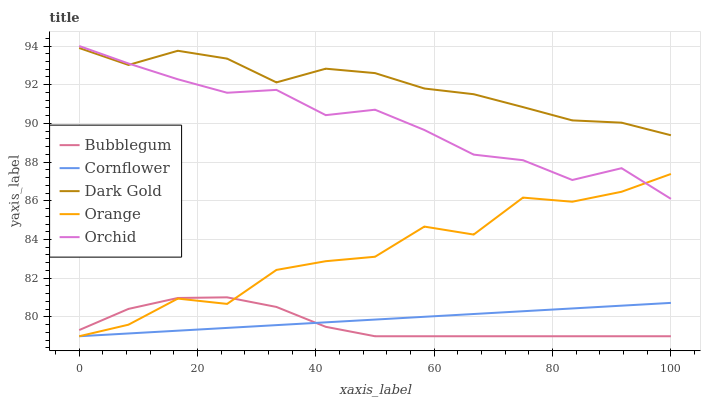Does Bubblegum have the minimum area under the curve?
Answer yes or no. Yes. Does Dark Gold have the maximum area under the curve?
Answer yes or no. Yes. Does Cornflower have the minimum area under the curve?
Answer yes or no. No. Does Cornflower have the maximum area under the curve?
Answer yes or no. No. Is Cornflower the smoothest?
Answer yes or no. Yes. Is Orange the roughest?
Answer yes or no. Yes. Is Orchid the smoothest?
Answer yes or no. No. Is Orchid the roughest?
Answer yes or no. No. Does Orange have the lowest value?
Answer yes or no. Yes. Does Orchid have the lowest value?
Answer yes or no. No. Does Orchid have the highest value?
Answer yes or no. Yes. Does Cornflower have the highest value?
Answer yes or no. No. Is Bubblegum less than Orchid?
Answer yes or no. Yes. Is Dark Gold greater than Cornflower?
Answer yes or no. Yes. Does Orange intersect Orchid?
Answer yes or no. Yes. Is Orange less than Orchid?
Answer yes or no. No. Is Orange greater than Orchid?
Answer yes or no. No. Does Bubblegum intersect Orchid?
Answer yes or no. No. 